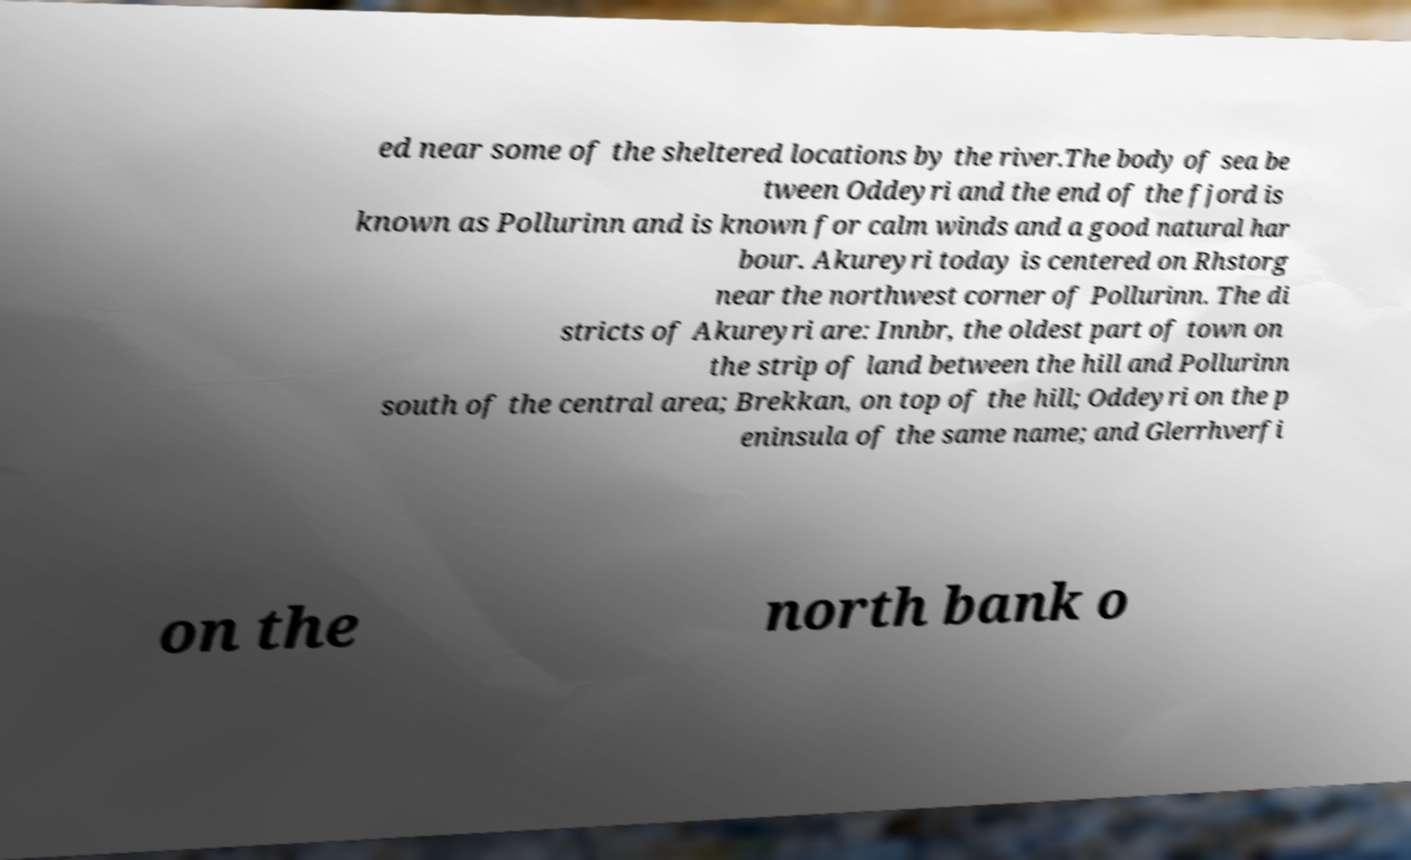Can you read and provide the text displayed in the image?This photo seems to have some interesting text. Can you extract and type it out for me? ed near some of the sheltered locations by the river.The body of sea be tween Oddeyri and the end of the fjord is known as Pollurinn and is known for calm winds and a good natural har bour. Akureyri today is centered on Rhstorg near the northwest corner of Pollurinn. The di stricts of Akureyri are: Innbr, the oldest part of town on the strip of land between the hill and Pollurinn south of the central area; Brekkan, on top of the hill; Oddeyri on the p eninsula of the same name; and Glerrhverfi on the north bank o 